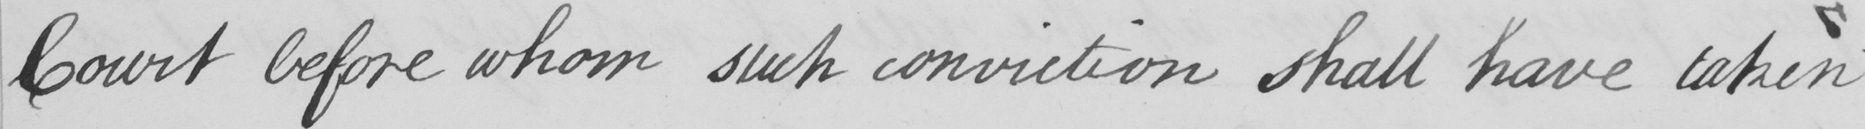Can you read and transcribe this handwriting? Court before whom such conviction shall have taken 